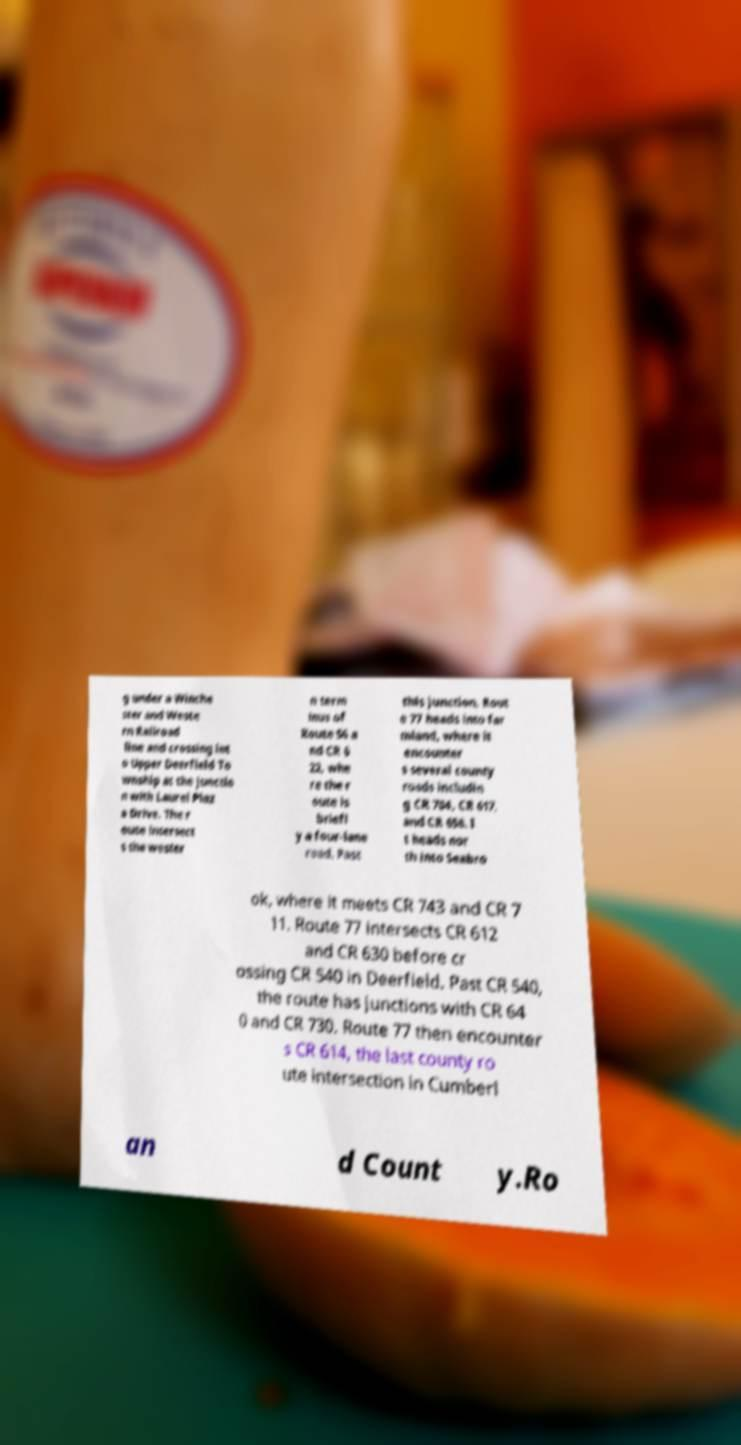Could you extract and type out the text from this image? g under a Winche ster and Weste rn Railroad line and crossing int o Upper Deerfield To wnship at the junctio n with Laurel Plaz a Drive. The r oute intersect s the wester n term inus of Route 56 a nd CR 6 22, whe re the r oute is briefl y a four-lane road. Past this junction, Rout e 77 heads into far mland, where it encounter s several county roads includin g CR 704, CR 617, and CR 658. I t heads nor th into Seabro ok, where it meets CR 743 and CR 7 11. Route 77 intersects CR 612 and CR 630 before cr ossing CR 540 in Deerfield. Past CR 540, the route has junctions with CR 64 0 and CR 730. Route 77 then encounter s CR 614, the last county ro ute intersection in Cumberl an d Count y.Ro 